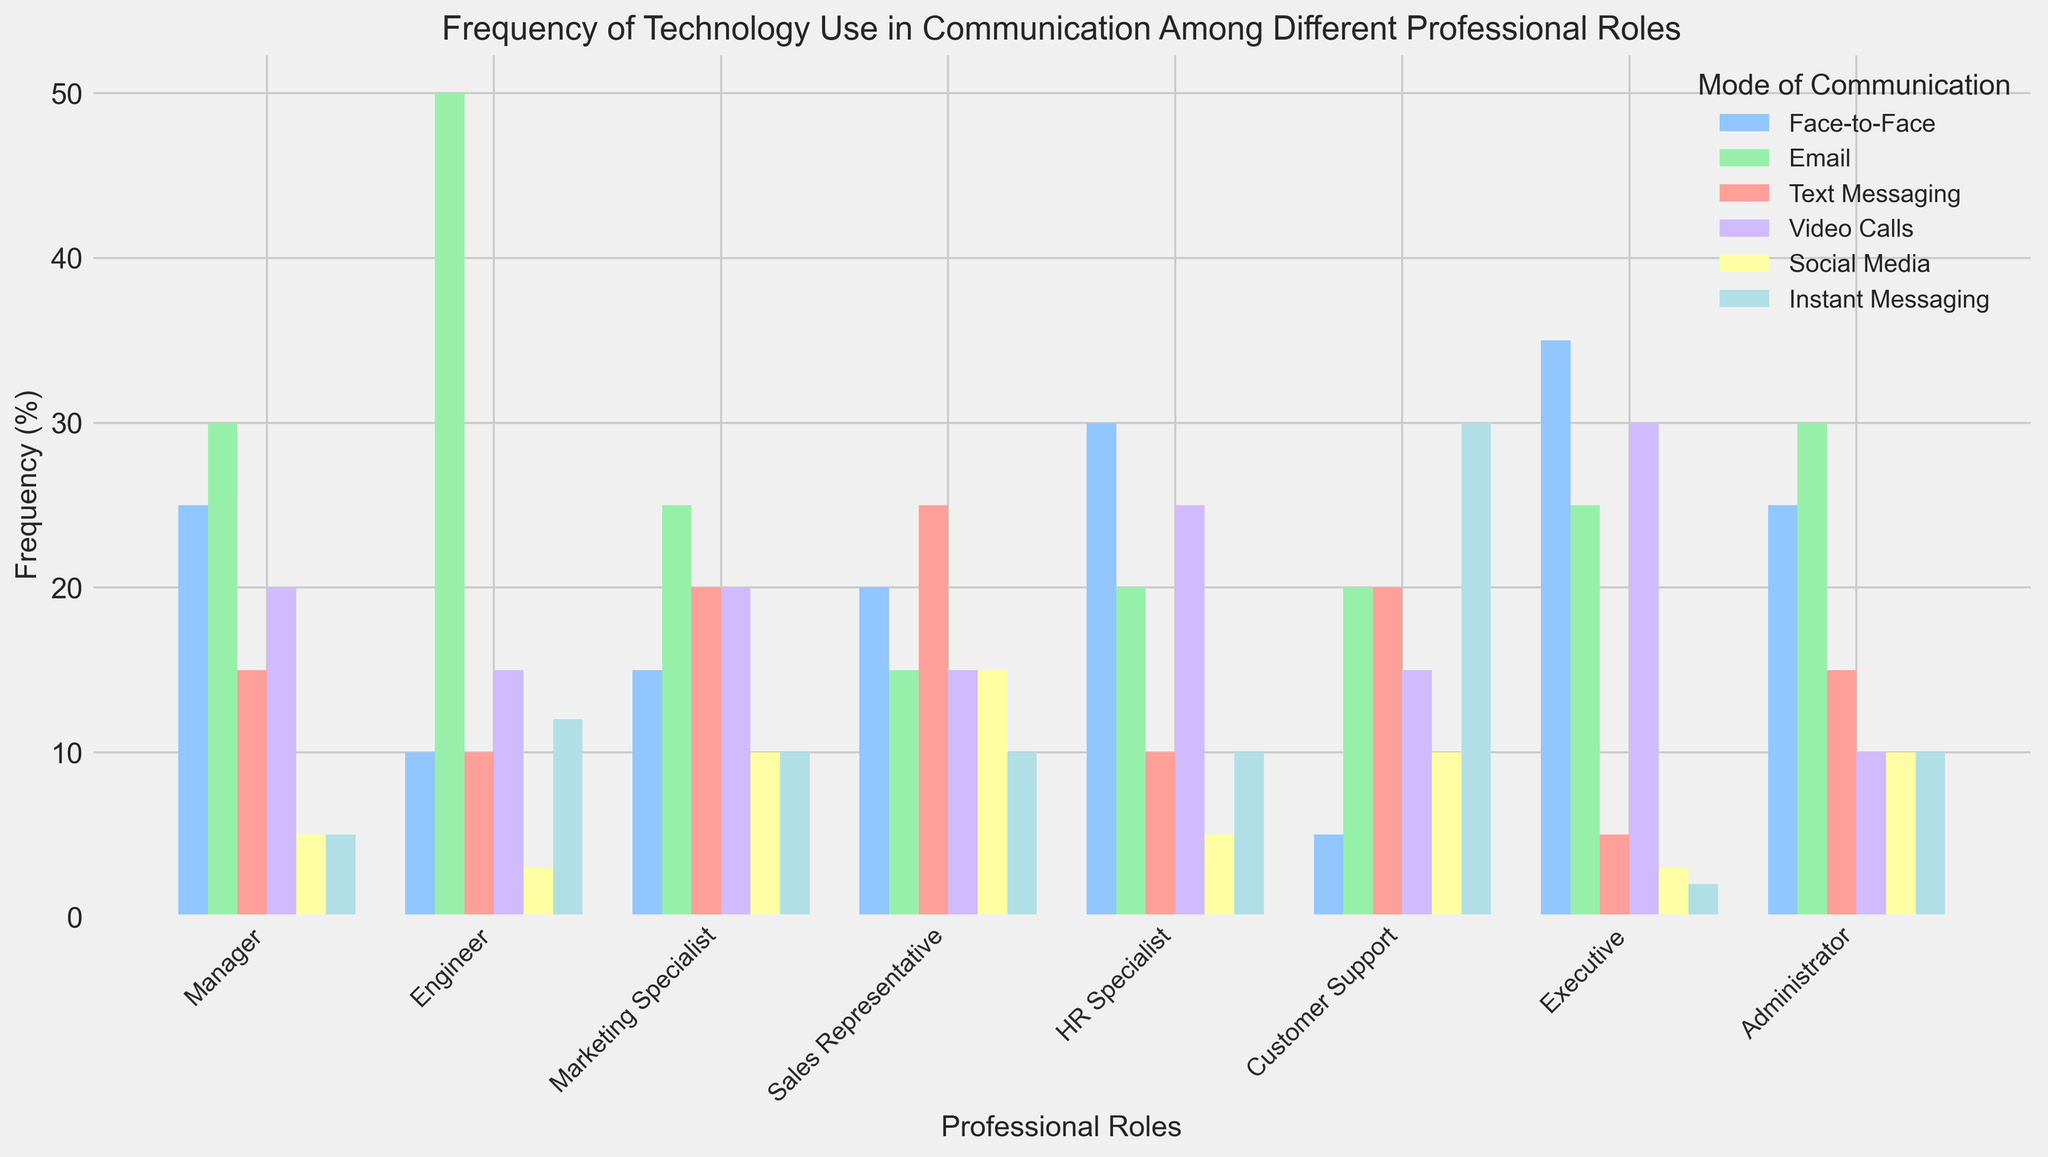What's the most frequently used mode of communication for Managers? By observing the highest bar for the Manager role, the bar for Email stands at 30% and is the tallest compared to other modes of communication.
Answer: Email Which professional role has the highest frequency of using Video Calls? By comparing the heights of the Video Calls bars for all roles, the Executive role has the highest bar at 30%.
Answer: Executive What is the total frequency of face-to-face communication for Managers and Executives combined? The frequency of face-to-face communication for Managers is 25%. For Executives, it is 35%. Summing these together gives 25 + 35 = 60.
Answer: 60 Are Engineers more likely to use Email than Instant Messaging? By comparing the heights of the Email and Instant Messaging bars for Engineers, the Email bar stands at 50%, which is higher than the Instant Messaging bar at 12%.
Answer: Yes Which mode of communication is least used by Marketing Specialists? By observing the shortest bar for the Marketing Specialist role, the bar for Social Media stands at 10%, which is the shortest.
Answer: Social Media Who uses Text Messaging more: Sales Representatives or Customer Support? Comparing the heights of the Text Messaging bars, Sales Representatives have a bar at 25%, while Customer Support has a bar at 20%.
Answer: Sales Representatives What is the average frequency of face-to-face communication across all roles? Summing the face-to-face communication values (25 + 10 + 15 + 20 + 30 + 5 + 35 + 25) gives 165. There are 8 roles, so the average is 165 / 8 = 20.625.
Answer: 20.625 How does the use of Social Media by Sales Representatives compare to that by Managers? Comparing the heights of the Social Media bars, Sales Representatives have a bar at 15%, while Managers have a bar at 5%.
Answer: Higher Which communication mode does the HR Specialist most frequently use? By observing the tallest bar for the HR Specialist role, the bar for Face-to-Face communication stands at 30%.
Answer: Face-to-Face 